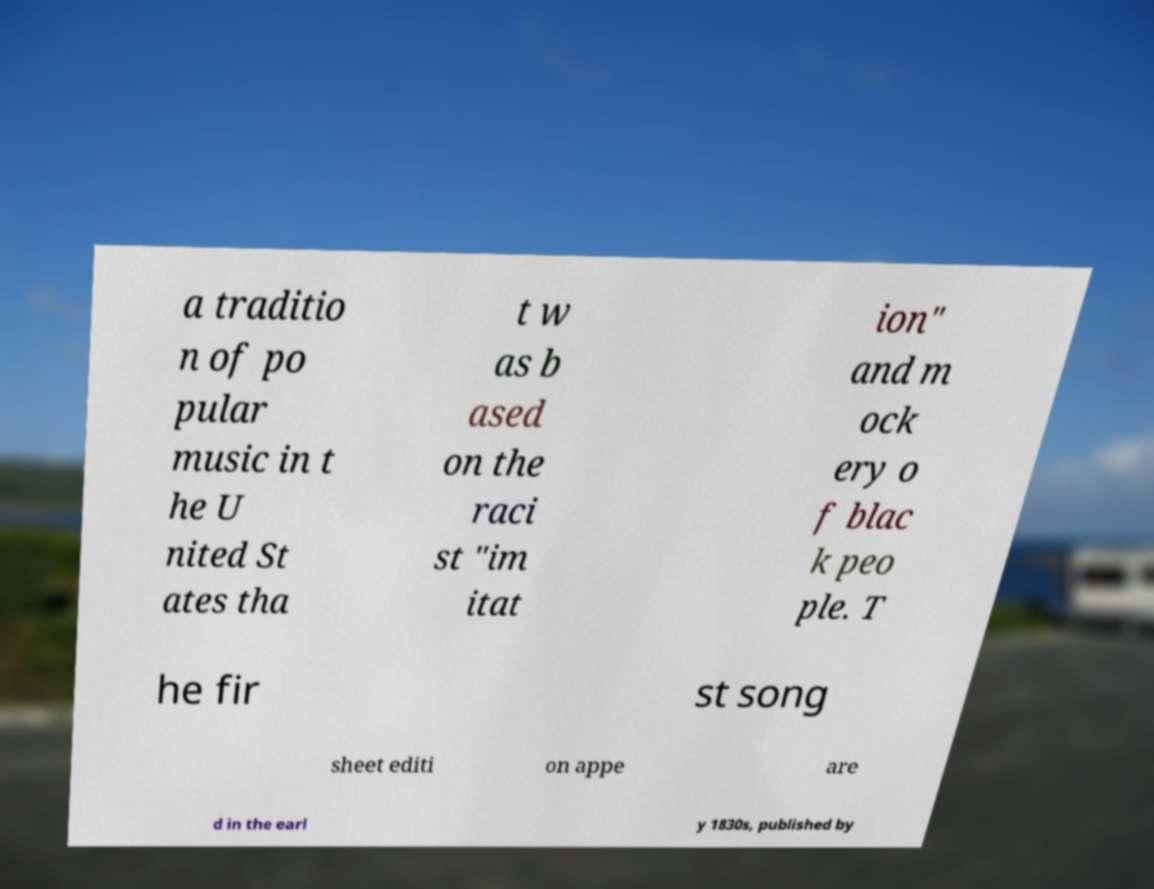I need the written content from this picture converted into text. Can you do that? a traditio n of po pular music in t he U nited St ates tha t w as b ased on the raci st "im itat ion" and m ock ery o f blac k peo ple. T he fir st song sheet editi on appe are d in the earl y 1830s, published by 